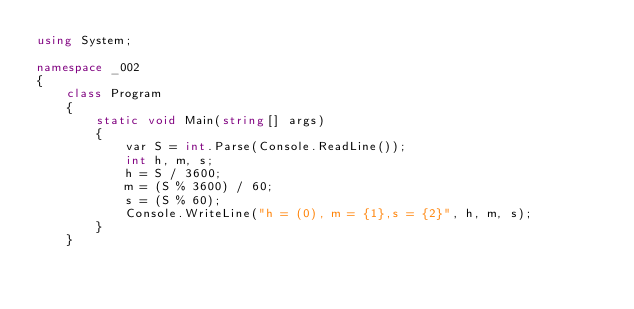<code> <loc_0><loc_0><loc_500><loc_500><_C#_>using System;

namespace _002
{
    class Program
    {
        static void Main(string[] args)
        {
            var S = int.Parse(Console.ReadLine());
            int h, m, s;
            h = S / 3600;
            m = (S % 3600) / 60;
            s = (S % 60);
            Console.WriteLine("h = (0), m = {1},s = {2}", h, m, s);
        }
    }
</code> 